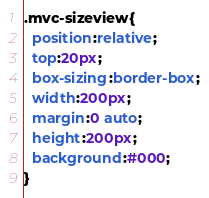Convert code to text. <code><loc_0><loc_0><loc_500><loc_500><_CSS_>.mvc-sizeview{
  position:relative;
  top:20px;
  box-sizing:border-box;
  width:200px;
  margin:0 auto;
  height:200px;
  background:#000;
}
</code> 